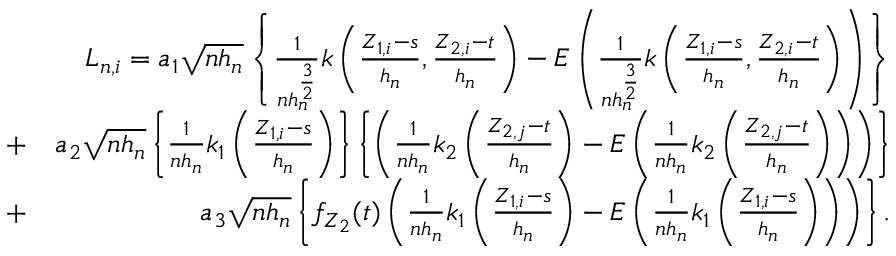Convert formula to latex. <formula><loc_0><loc_0><loc_500><loc_500>\begin{array} { r l r } & { L _ { n , i } = a _ { 1 } \sqrt { n h _ { n } } \left \{ \frac { 1 } { n h _ { n } ^ { \frac { 3 } { 2 } } } k \left ( \frac { Z _ { 1 , i } - s } { h _ { n } } , \frac { Z _ { 2 , i } - t } { h _ { n } } \right ) - E \left ( \frac { 1 } { n h _ { n } ^ { \frac { 3 } { 2 } } } k \left ( \frac { Z _ { 1 , i } - s } { h _ { n } } , \frac { Z _ { 2 , i } - t } { h _ { n } } \right ) \right ) \right \} } \\ & { + } & { a _ { 2 } \sqrt { n h _ { n } } \left \{ \frac { 1 } { n h _ { n } } k _ { 1 } \left ( \frac { Z _ { 1 , i } - s } { h _ { n } } \right ) \right \} \left \{ \left ( \frac { 1 } { n h _ { n } } k _ { 2 } \left ( \frac { Z _ { 2 , j } - t } { h _ { n } } \right ) - E \left ( \frac { 1 } { n h _ { n } } k _ { 2 } \left ( \frac { Z _ { 2 , j } - t } { h _ { n } } \right ) \right ) \right ) \right \} } \\ & { + } & { a _ { 3 } \sqrt { n h _ { n } } \left \{ f _ { Z _ { 2 } } ( t ) \left ( \frac { 1 } { n h _ { n } } k _ { 1 } \left ( \frac { Z _ { 1 , i } - s } { h _ { n } } \right ) - E \left ( \frac { 1 } { n h _ { n } } k _ { 1 } \left ( \frac { Z _ { 1 , i } - s } { h _ { n } } \right ) \right ) \right ) \right \} . } \end{array}</formula> 